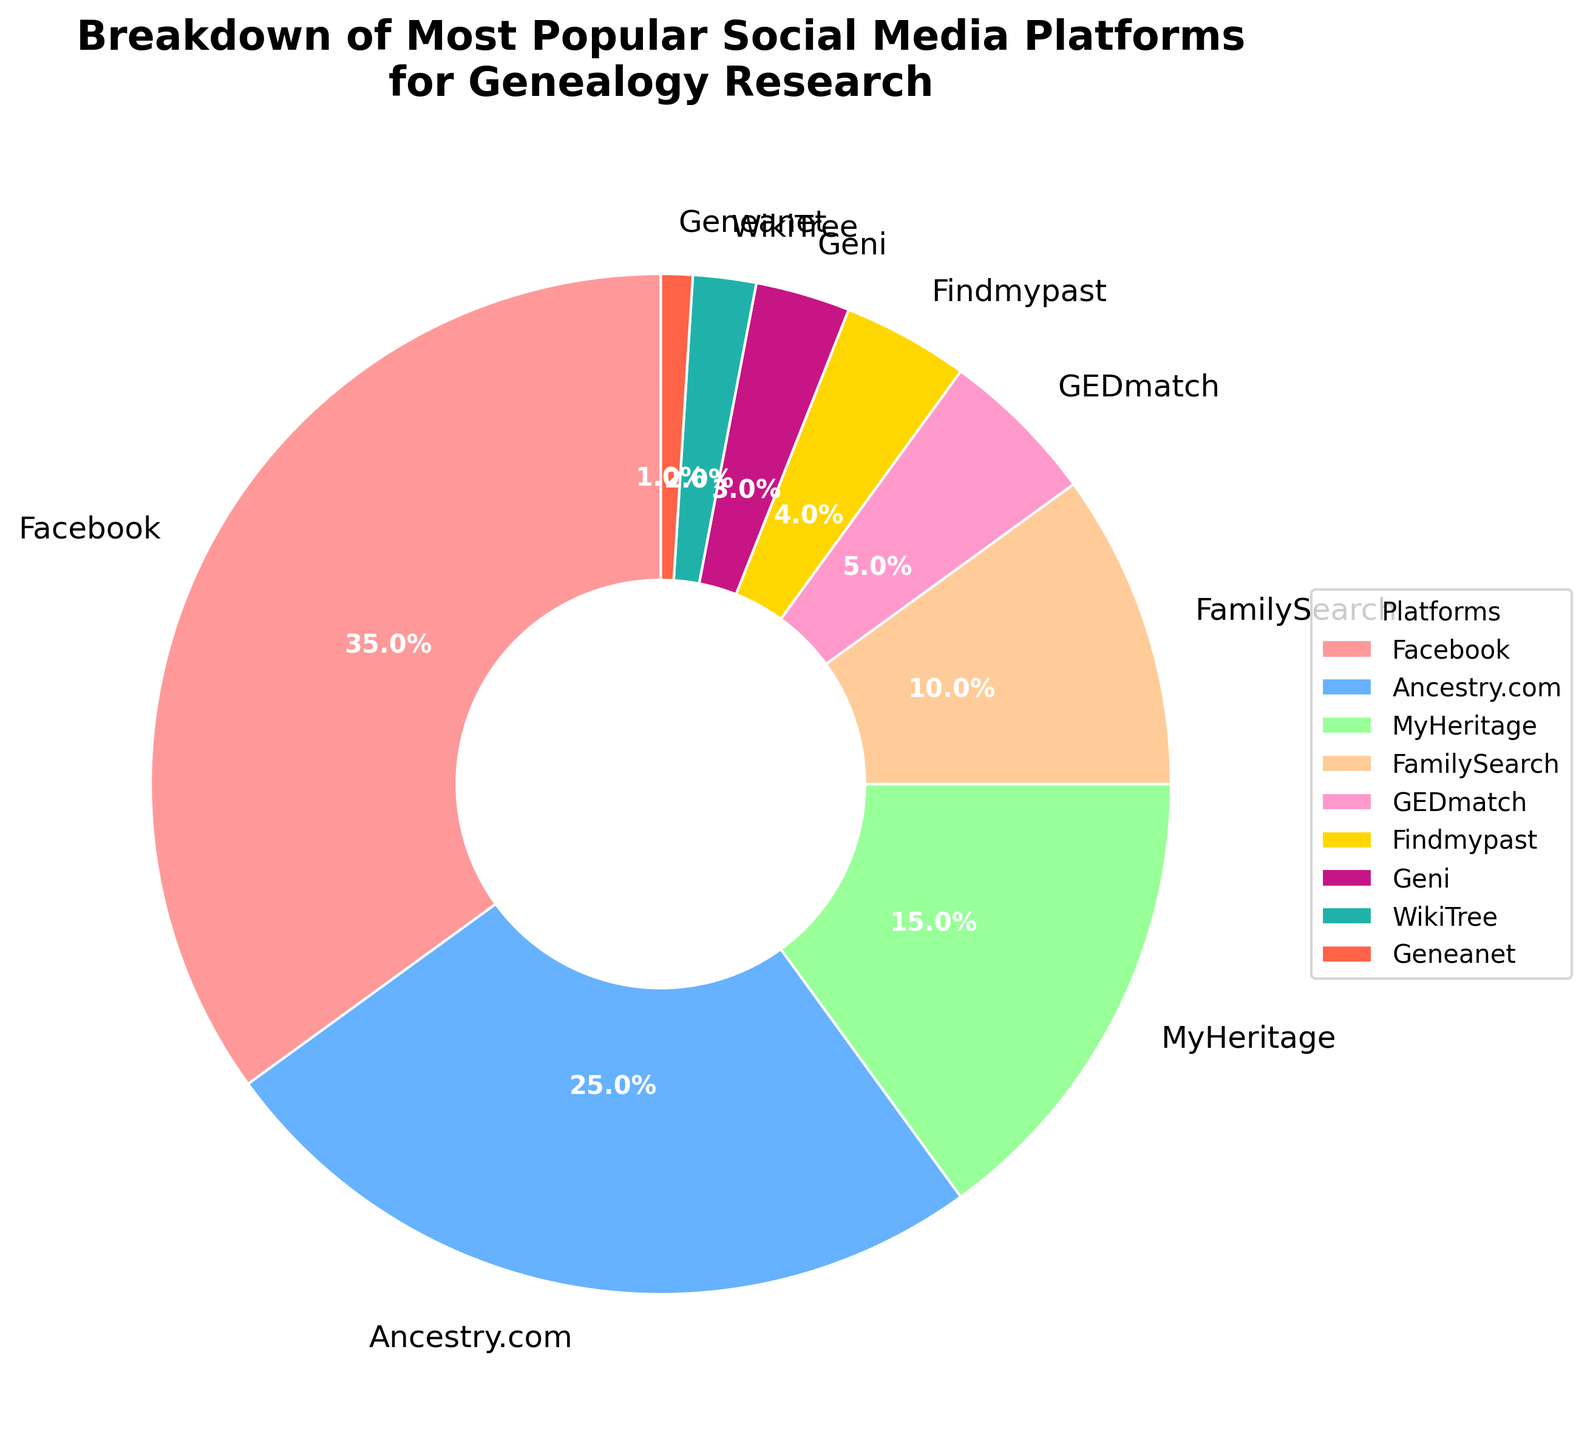Which platform has the highest percentage of usage for genealogy research? The pie chart shows that Facebook occupies the largest segment. Observing the labels, Facebook is listed with the largest percentage of 35%.
Answer: Facebook What is the combined percentage of Ancestry.com and MyHeritage? To find the combined percentage, add the percentages of Ancestry.com and MyHeritage: 25% (Ancestry.com) + 15% (MyHeritage) = 40%.
Answer: 40% Which platform has a smaller percentage, GEDmatch or Findmypast? By comparing the percentages in the chart, GEDmatch has a percentage of 5%, whereas Findmypast has 4%. Findmypast has a smaller percentage.
Answer: Findmypast How much larger is the percentage of usage for FamilySearch compared to WikiTree? Subtract the percentage of WikiTree from that of FamilySearch: 10% (FamilySearch) - 2% (WikiTree) = 8%.
Answer: 8% Rank the platforms in descending order based on their usage percentages. From the largest to the smallest percentage, the platforms are: Facebook (35%), Ancestry.com (25%), MyHeritage (15%), FamilySearch (10%), GEDmatch (5%), Findmypast (4%), Geni (3%), WikiTree (2%), Geneanet (1%).
Answer: Facebook, Ancestry.com, MyHeritage, FamilySearch, GEDmatch, Findmypast, Geni, WikiTree, Geneanet What is the difference in the combined percentage of Facebook and Ancestry.com compared to the combined percentage of Geni and WikiTree? First calculate the combined percentage of Facebook and Ancestry.com: 35% + 25% = 60%. Then calculate the combined percentage of Geni and WikiTree: 3% + 2% = 5%. The difference is 60% - 5% = 55%.
Answer: 55% Which platforms have percentages that are within 5% of each other? Looking at the percentages: 
- FamilySearch (10%) and GEDmatch (5%) have a difference of 5%.
- Findmypast (4%) and Geni (3%) have a difference of 1%.
- WikITree (2%) and Geneanet (1%) have a difference of 1%.
Answer: FamilySearch and GEDmatch; Findmypast and Geni; WikiTree and Geneanet What percentage of the pie chart is occupied by the three least popular platforms? The three least popular platforms are WikiTree (2%), Geneanet (1%), and Geni (3%). Adding these percentages: 2% + 1% + 3% = 6%.
Answer: 6% Which platforms use warm colors (like red, pink, or yellow) and what is their combined percentage? By observing the colors:
- Facebook (35%, red).
- Findmypast (4%, yellow).
- Geni (3%, pink).
- Geneanet (1%, red-orange). 
Combining their percentages: 35% + 4% + 3% + 1% = 43%.
Answer: 43% What is the total percentage for platforms with a percentage greater than or equal to 10%? Identify the platforms: Facebook (35%), Ancestry.com (25%), MyHeritage (15%), FamilySearch (10%). Add these percentages: 35% + 25% + 15% + 10% = 85%.
Answer: 85% 